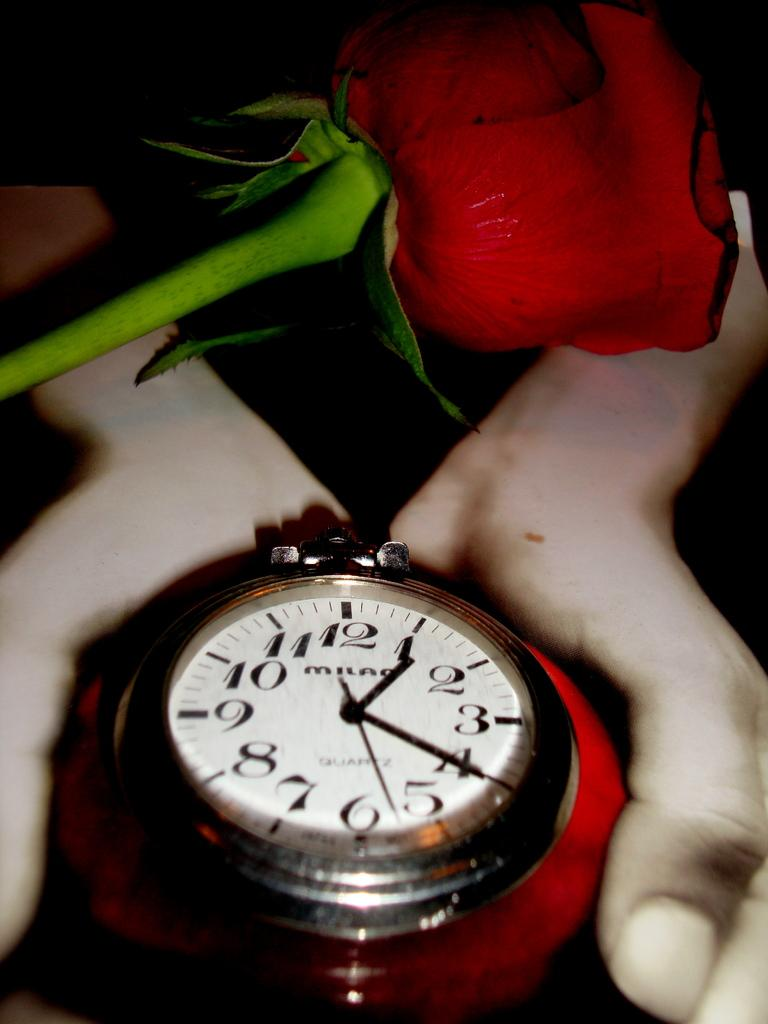<image>
Relay a brief, clear account of the picture shown. Someone holds a red rose and watch that tells us it is 1:20 